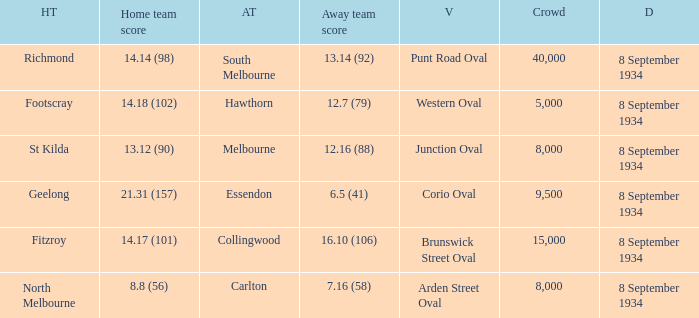When Melbourne was the Away team, what was their score? 12.16 (88). 